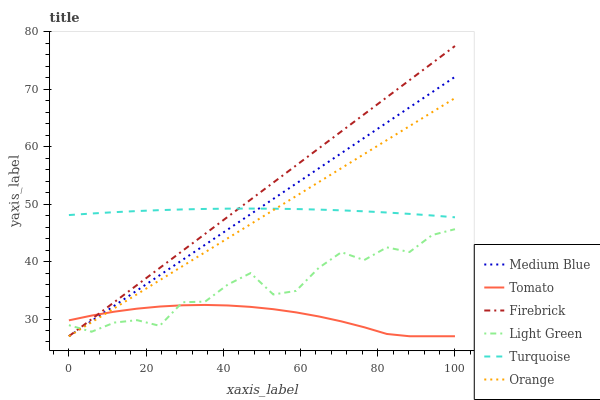Does Tomato have the minimum area under the curve?
Answer yes or no. Yes. Does Firebrick have the maximum area under the curve?
Answer yes or no. Yes. Does Turquoise have the minimum area under the curve?
Answer yes or no. No. Does Turquoise have the maximum area under the curve?
Answer yes or no. No. Is Orange the smoothest?
Answer yes or no. Yes. Is Light Green the roughest?
Answer yes or no. Yes. Is Turquoise the smoothest?
Answer yes or no. No. Is Turquoise the roughest?
Answer yes or no. No. Does Tomato have the lowest value?
Answer yes or no. Yes. Does Turquoise have the lowest value?
Answer yes or no. No. Does Firebrick have the highest value?
Answer yes or no. Yes. Does Turquoise have the highest value?
Answer yes or no. No. Is Tomato less than Turquoise?
Answer yes or no. Yes. Is Turquoise greater than Tomato?
Answer yes or no. Yes. Does Tomato intersect Orange?
Answer yes or no. Yes. Is Tomato less than Orange?
Answer yes or no. No. Is Tomato greater than Orange?
Answer yes or no. No. Does Tomato intersect Turquoise?
Answer yes or no. No. 